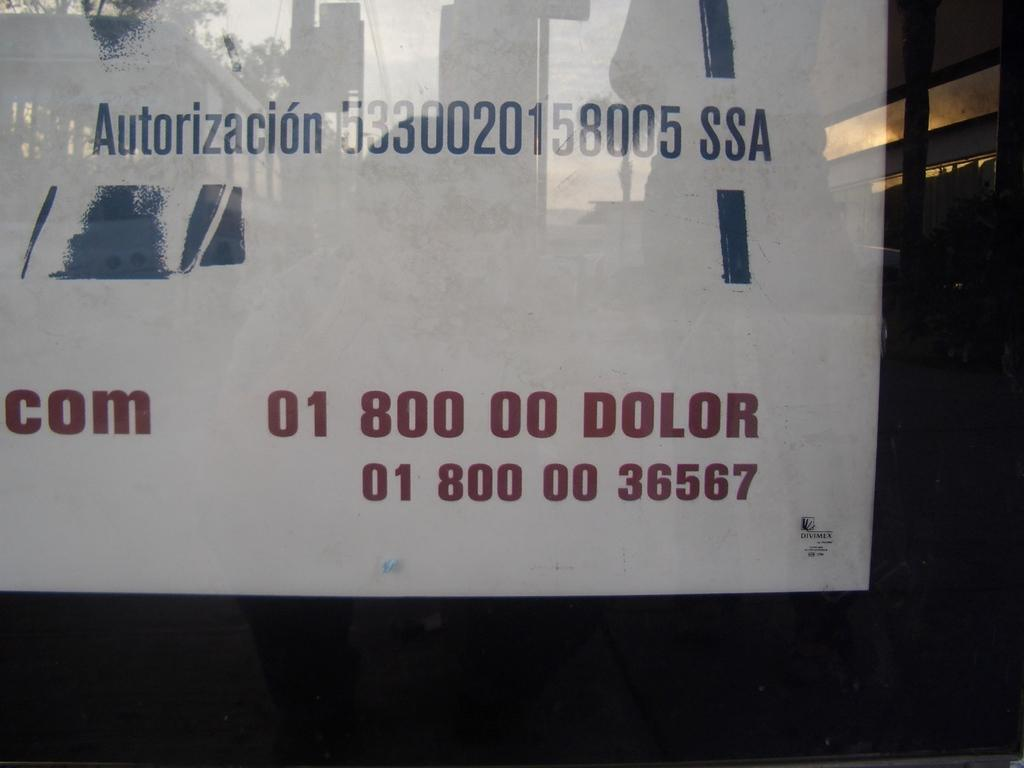What is present on the glass wall in the image? There is a paper attached to the glass wall in the image. What is written on the glass wall? There are numbers written on the glass wall. Can you see any signs of a skate-related wound on the paper in the image? There is no indication of a wound or any skate-related elements in the image. 